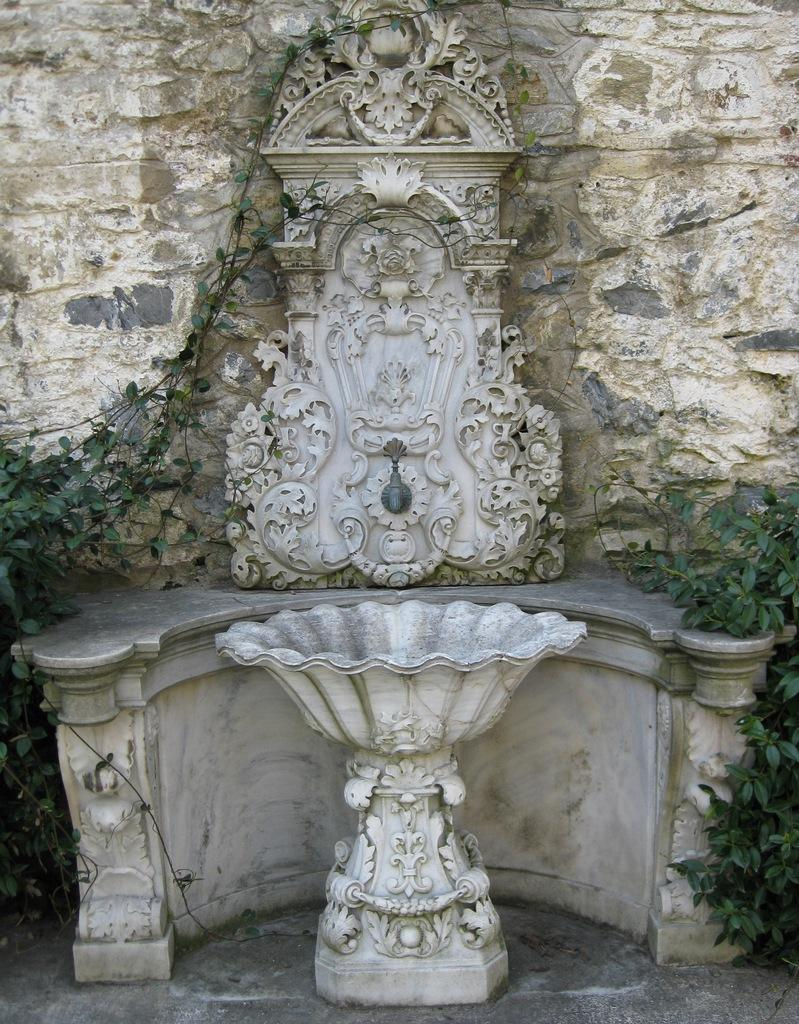What is the white object or area in the image? The white object or area in the image is not specified, but it is present. What can be seen on the wall in the image? There are designs on the wall in the image. What type of vegetation is visible in the image? There are plants visible in the image. Who is the aunt mentioned in the image? There is no mention of an aunt in the image. What type of wilderness can be seen in the image? There is no wilderness present in the image. 